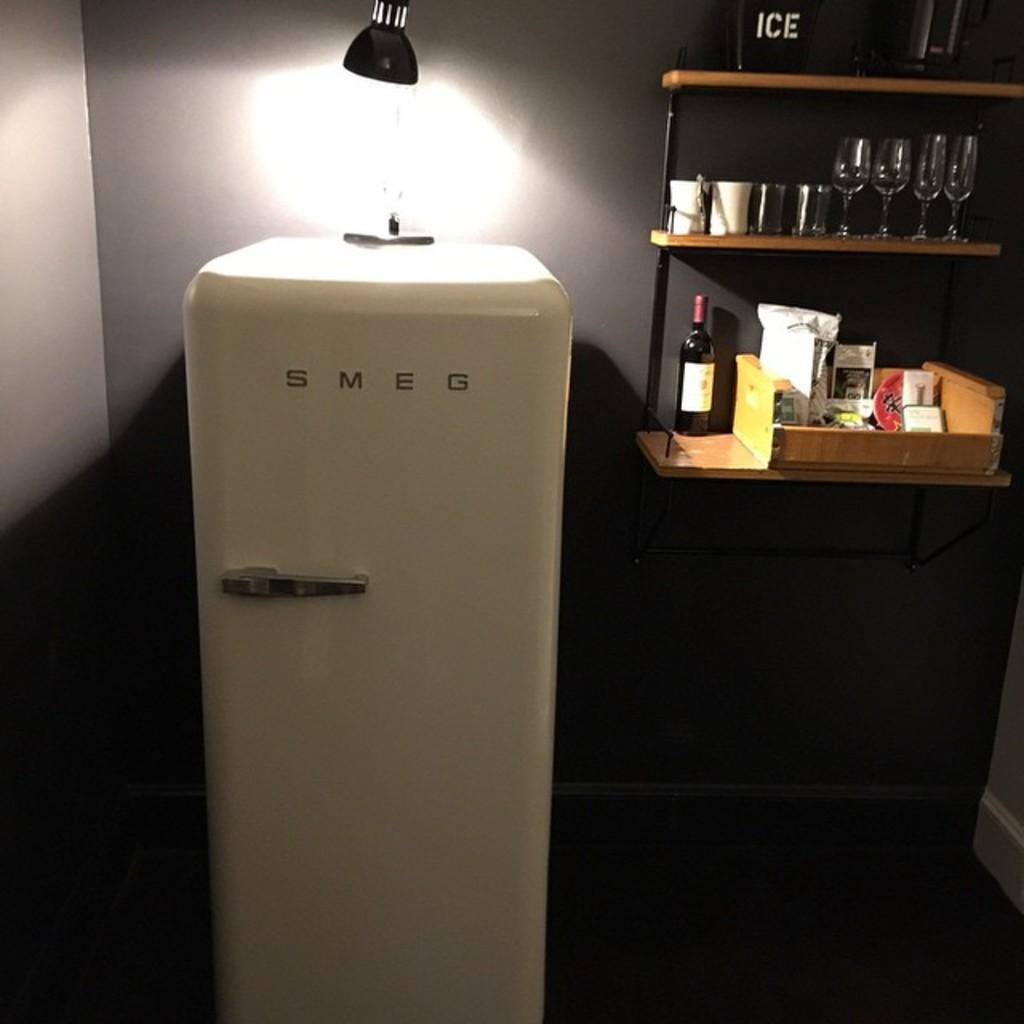<image>
Present a compact description of the photo's key features. Refrigerator and wine glasses, ice, and wine bottle on a shelf, the refrigerator says SMEG. 